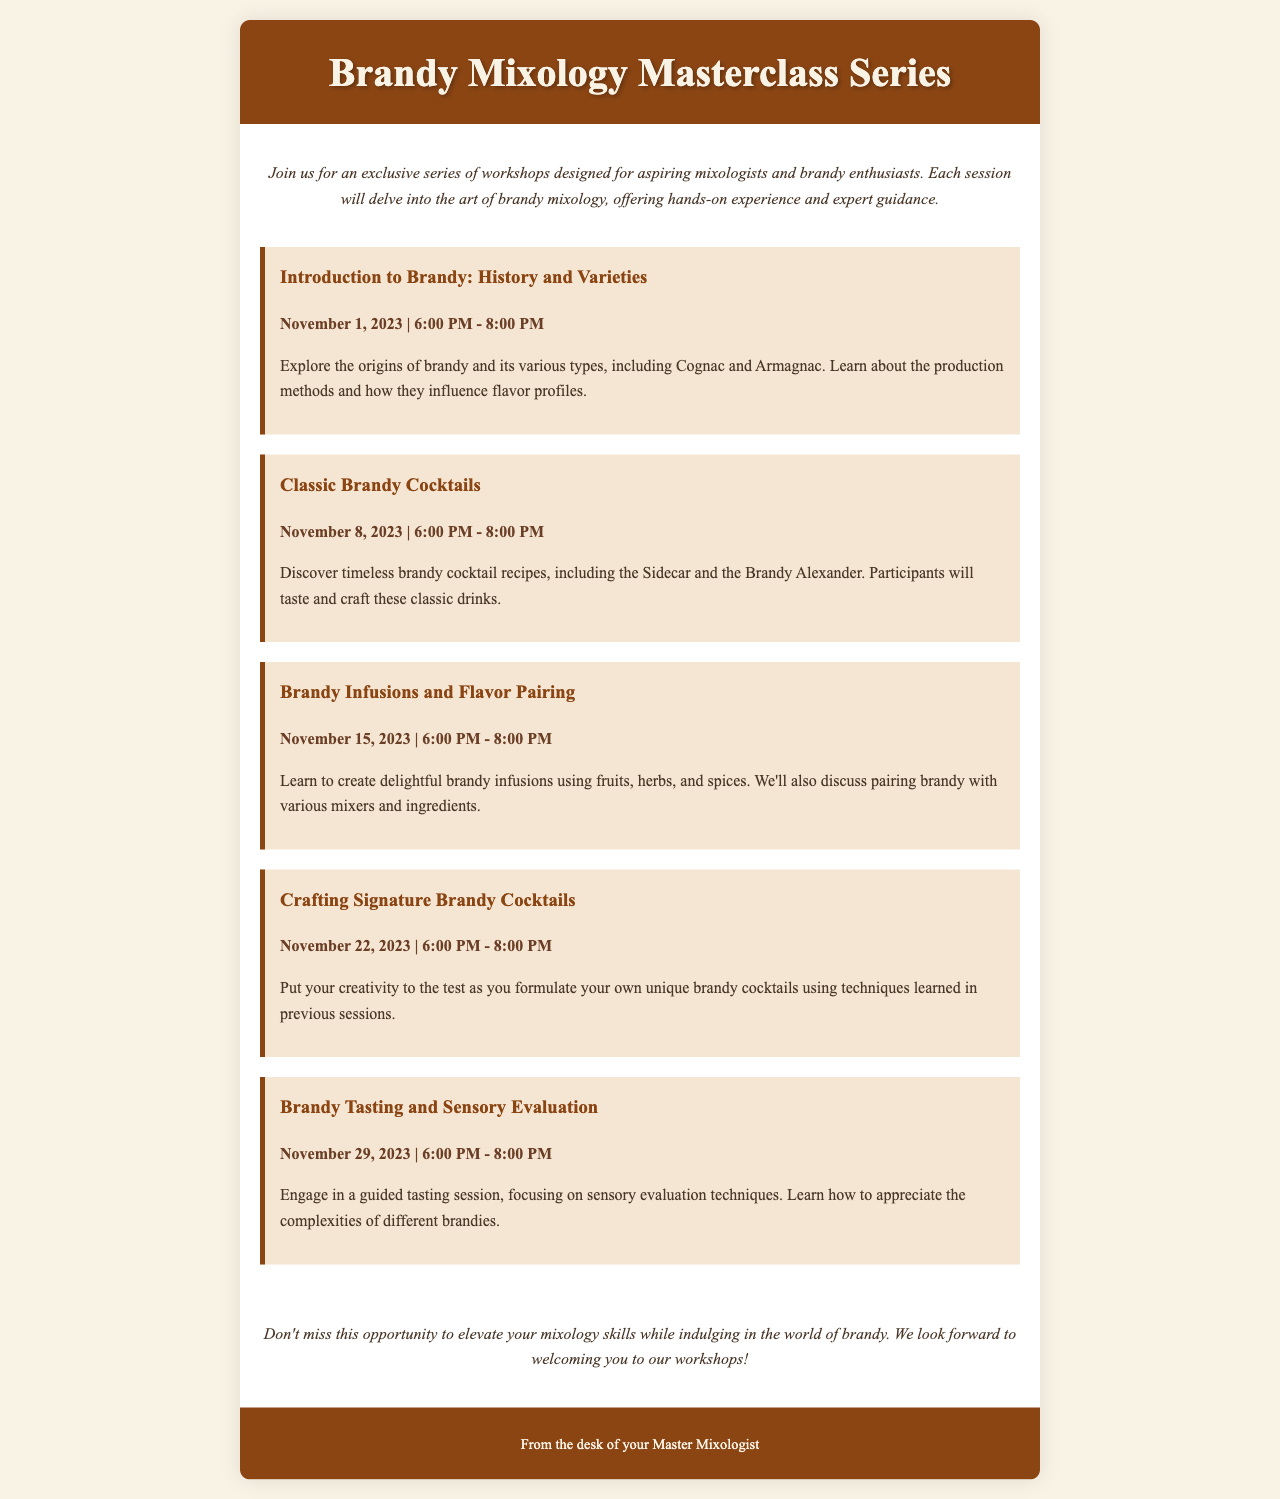What is the title of the workshop series? The title of the workshop series is prominently displayed in the header of the document.
Answer: Brandy Mixology Masterclass Series How many sessions are included in the workshop series? The number of sessions can be counted from the individual session sections provided in the document.
Answer: Five What is the topic of the third session? The topic of the third session is explicitly mentioned in the session title.
Answer: Brandy Infusions and Flavor Pairing What technique will be focused on during the fifth session? The specific focus of the fifth session is addressed in its description.
Answer: Sensory evaluation techniques What cocktail will participants learn to craft in the second session? A specific cocktail mentioned in the second session description indicates what participants will learn.
Answer: Sidecar When is the final session scheduled? The date of the final session is provided in the listing of the sessions.
Answer: November 29, 2023 What is the main goal of the workshop series? The goal of the workshop series is summarized in the introduction and conclusion sections.
Answer: To elevate mixology skills What will participants create during the fourth session? The description of the fourth session specifies what participants will do.
Answer: Unique brandy cocktails 